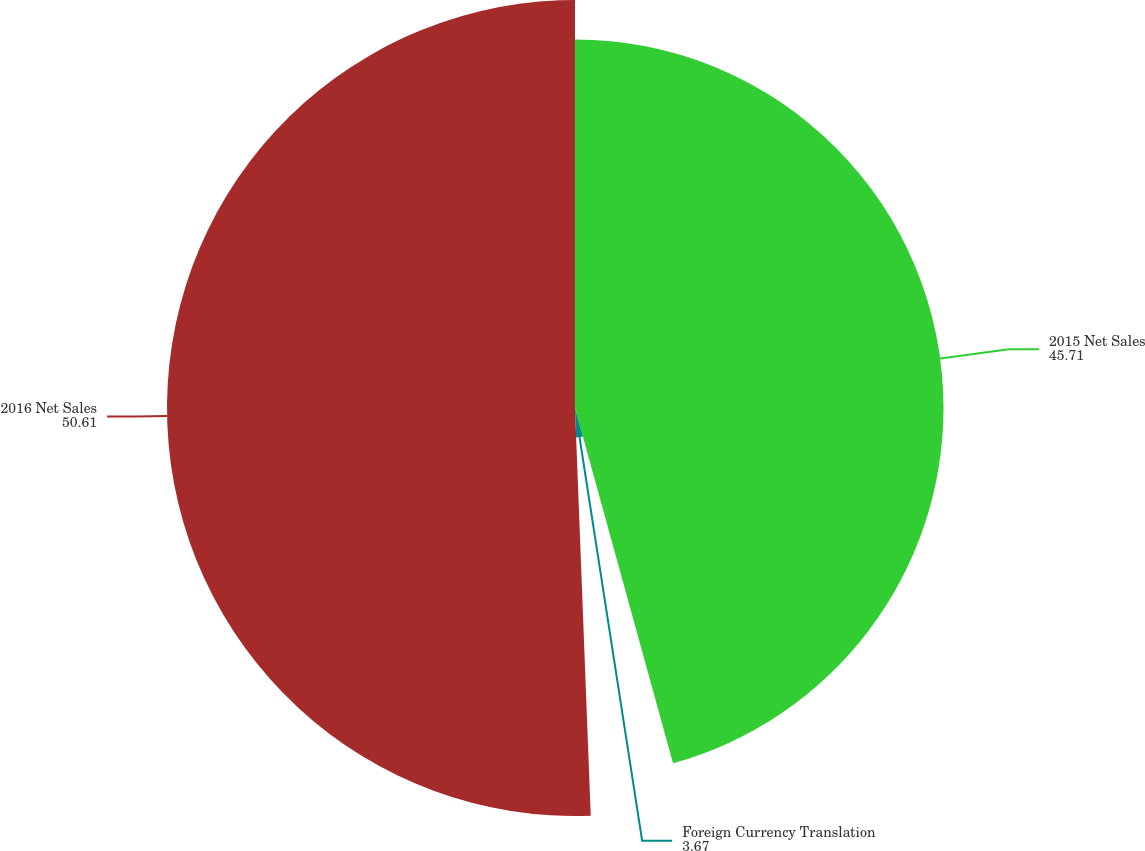Convert chart to OTSL. <chart><loc_0><loc_0><loc_500><loc_500><pie_chart><fcel>2015 Net Sales<fcel>Foreign Currency Translation<fcel>2016 Net Sales<nl><fcel>45.71%<fcel>3.67%<fcel>50.61%<nl></chart> 